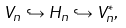<formula> <loc_0><loc_0><loc_500><loc_500>V _ { n } \hookrightarrow H _ { n } \hookrightarrow V _ { n } ^ { * } ,</formula> 